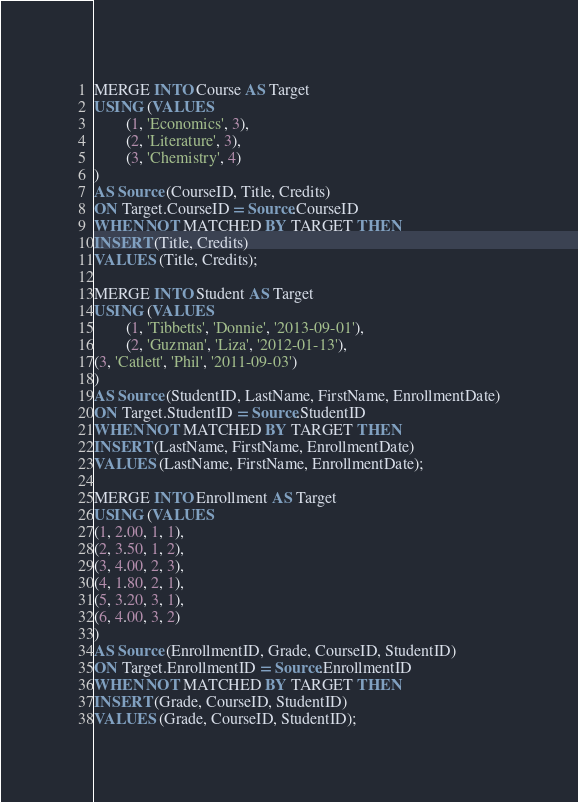<code> <loc_0><loc_0><loc_500><loc_500><_SQL_>MERGE INTO Course AS Target 
USING (VALUES 
        (1, 'Economics', 3), 
        (2, 'Literature', 3), 
        (3, 'Chemistry', 4)
) 
AS Source (CourseID, Title, Credits) 
ON Target.CourseID = Source.CourseID 
WHEN NOT MATCHED BY TARGET THEN 
INSERT (Title, Credits) 
VALUES (Title, Credits);

MERGE INTO Student AS Target
USING (VALUES 
        (1, 'Tibbetts', 'Donnie', '2013-09-01'), 
        (2, 'Guzman', 'Liza', '2012-01-13'), 
(3, 'Catlett', 'Phil', '2011-09-03')
)
AS Source (StudentID, LastName, FirstName, EnrollmentDate)
ON Target.StudentID = Source.StudentID
WHEN NOT MATCHED BY TARGET THEN
INSERT (LastName, FirstName, EnrollmentDate)
VALUES (LastName, FirstName, EnrollmentDate);

MERGE INTO Enrollment AS Target
USING (VALUES 
(1, 2.00, 1, 1),
(2, 3.50, 1, 2),
(3, 4.00, 2, 3),
(4, 1.80, 2, 1),
(5, 3.20, 3, 1),
(6, 4.00, 3, 2)
)
AS Source (EnrollmentID, Grade, CourseID, StudentID)
ON Target.EnrollmentID = Source.EnrollmentID
WHEN NOT MATCHED BY TARGET THEN
INSERT (Grade, CourseID, StudentID)
VALUES (Grade, CourseID, StudentID);</code> 